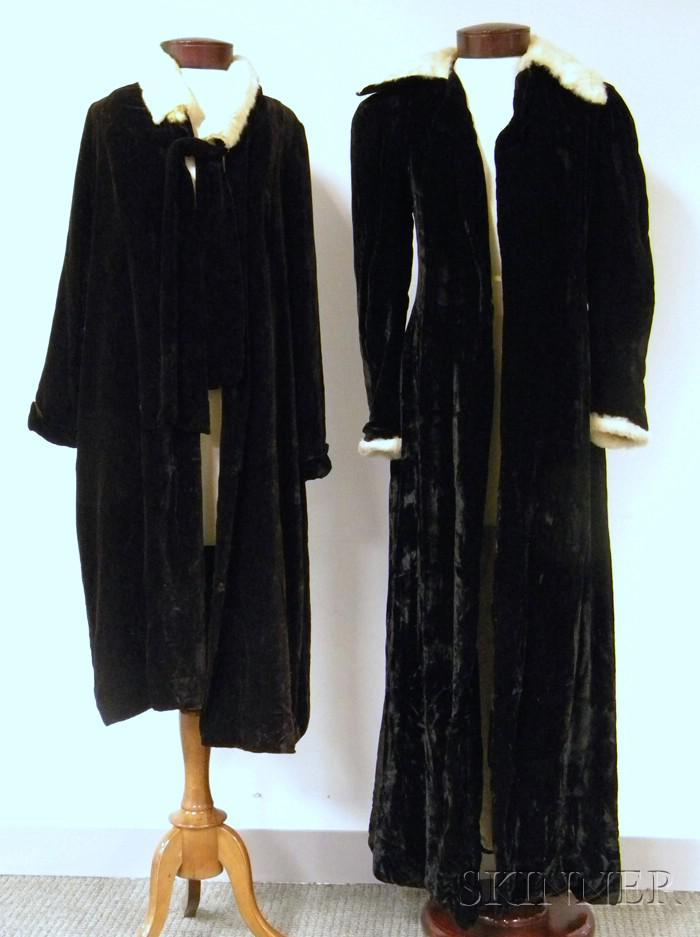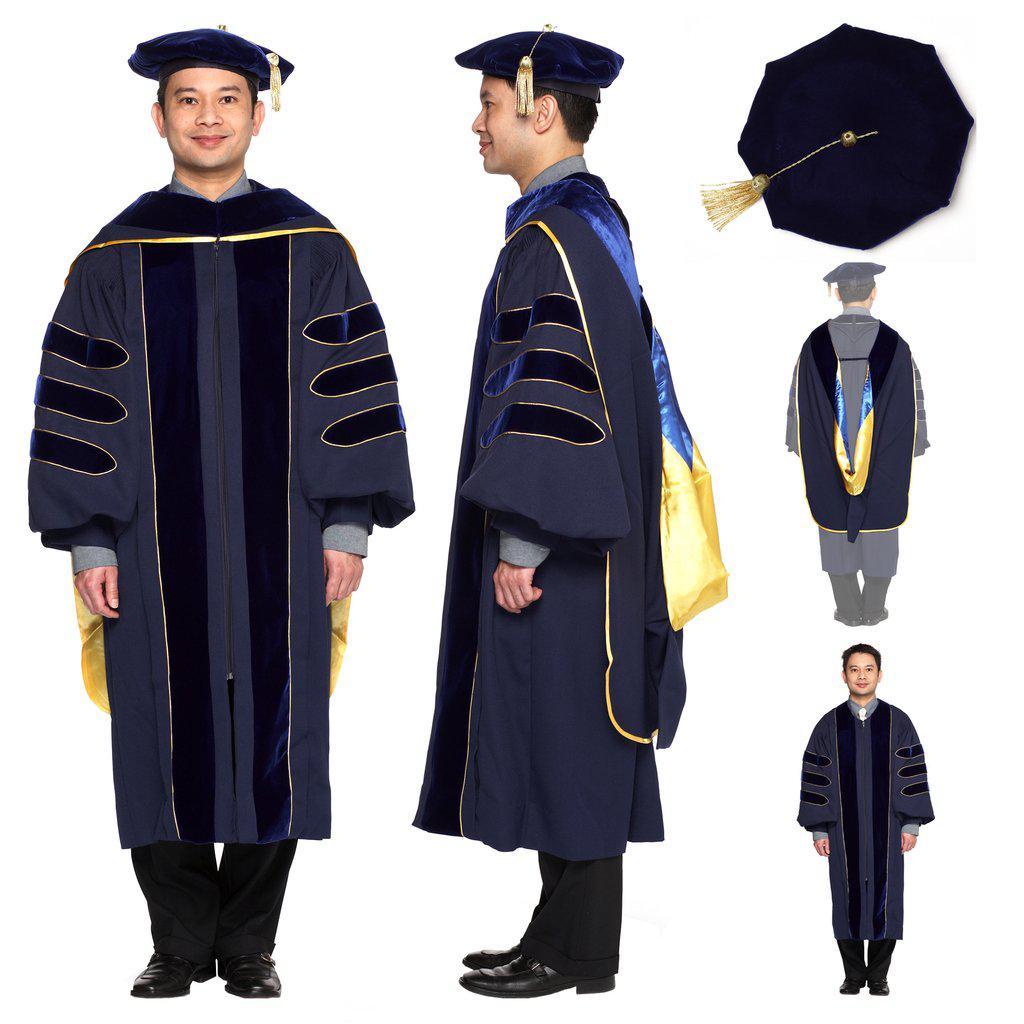The first image is the image on the left, the second image is the image on the right. Given the left and right images, does the statement "In the left image, you will find no people." hold true? Answer yes or no. Yes. The first image is the image on the left, the second image is the image on the right. Analyze the images presented: Is the assertion "There are at most 4 graduation gowns in the image pair" valid? Answer yes or no. No. 